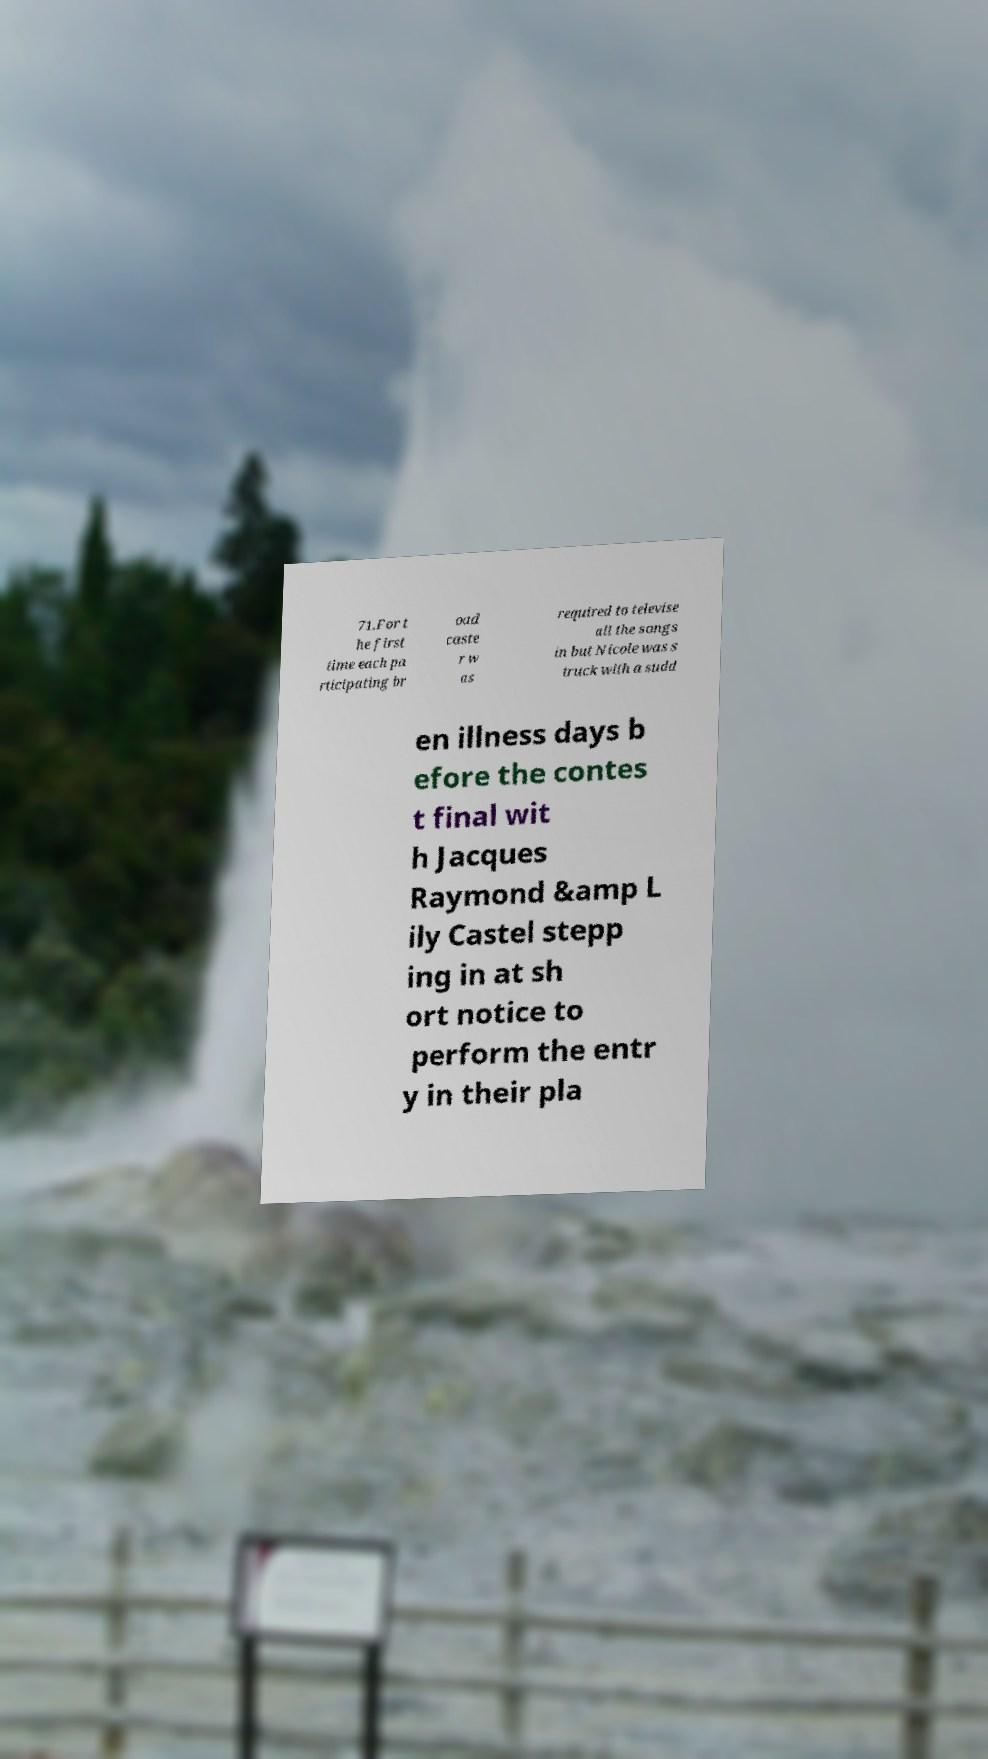There's text embedded in this image that I need extracted. Can you transcribe it verbatim? 71.For t he first time each pa rticipating br oad caste r w as required to televise all the songs in but Nicole was s truck with a sudd en illness days b efore the contes t final wit h Jacques Raymond &amp L ily Castel stepp ing in at sh ort notice to perform the entr y in their pla 